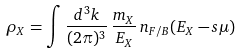Convert formula to latex. <formula><loc_0><loc_0><loc_500><loc_500>\rho _ { X } = \int \frac { d ^ { 3 } k } { ( 2 \pi ) ^ { 3 } } \, \frac { m _ { X } } { E _ { X } } \, n _ { F / B } ( E _ { X } - s \mu )</formula> 